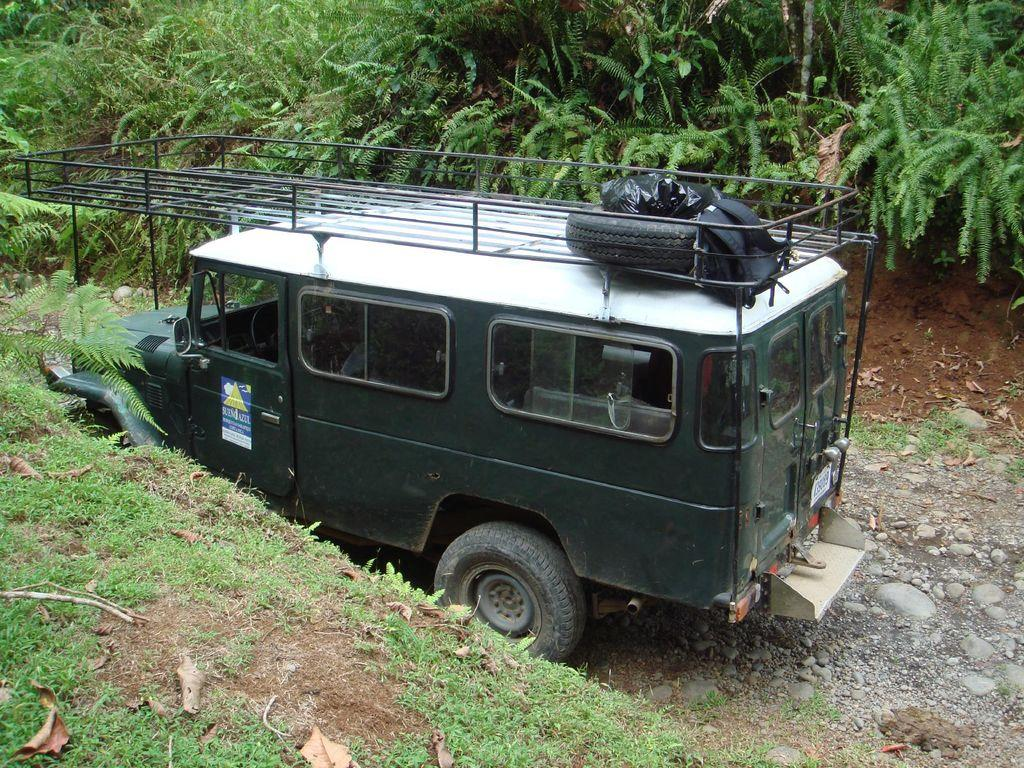What is the main subject in the image? There is a vehicle in the image. What type of natural elements can be seen in the image? There are trees, plants, stones, leaves, and grass in the image. What type of spade is being used to dig up the grass in the image? There is no spade present in the image; it features a vehicle, trees, plants, stones, leaves, and grass. What is the weather like in the image? The provided facts do not mention the weather, so we cannot determine the weather from the image. 